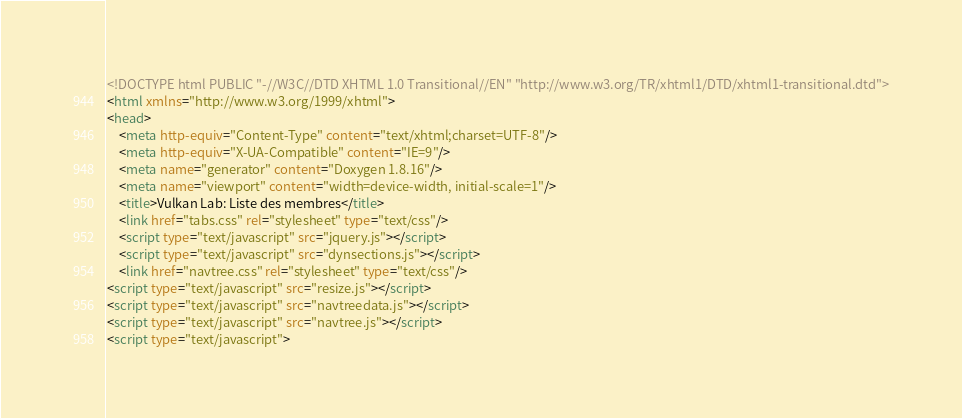Convert code to text. <code><loc_0><loc_0><loc_500><loc_500><_HTML_><!DOCTYPE html PUBLIC "-//W3C//DTD XHTML 1.0 Transitional//EN" "http://www.w3.org/TR/xhtml1/DTD/xhtml1-transitional.dtd">
<html xmlns="http://www.w3.org/1999/xhtml">
<head>
    <meta http-equiv="Content-Type" content="text/xhtml;charset=UTF-8"/>
    <meta http-equiv="X-UA-Compatible" content="IE=9"/>
    <meta name="generator" content="Doxygen 1.8.16"/>
    <meta name="viewport" content="width=device-width, initial-scale=1"/>
    <title>Vulkan Lab: Liste des membres</title>
    <link href="tabs.css" rel="stylesheet" type="text/css"/>
    <script type="text/javascript" src="jquery.js"></script>
    <script type="text/javascript" src="dynsections.js"></script>
    <link href="navtree.css" rel="stylesheet" type="text/css"/>
<script type="text/javascript" src="resize.js"></script>
<script type="text/javascript" src="navtreedata.js"></script>
<script type="text/javascript" src="navtree.js"></script>
<script type="text/javascript"></code> 